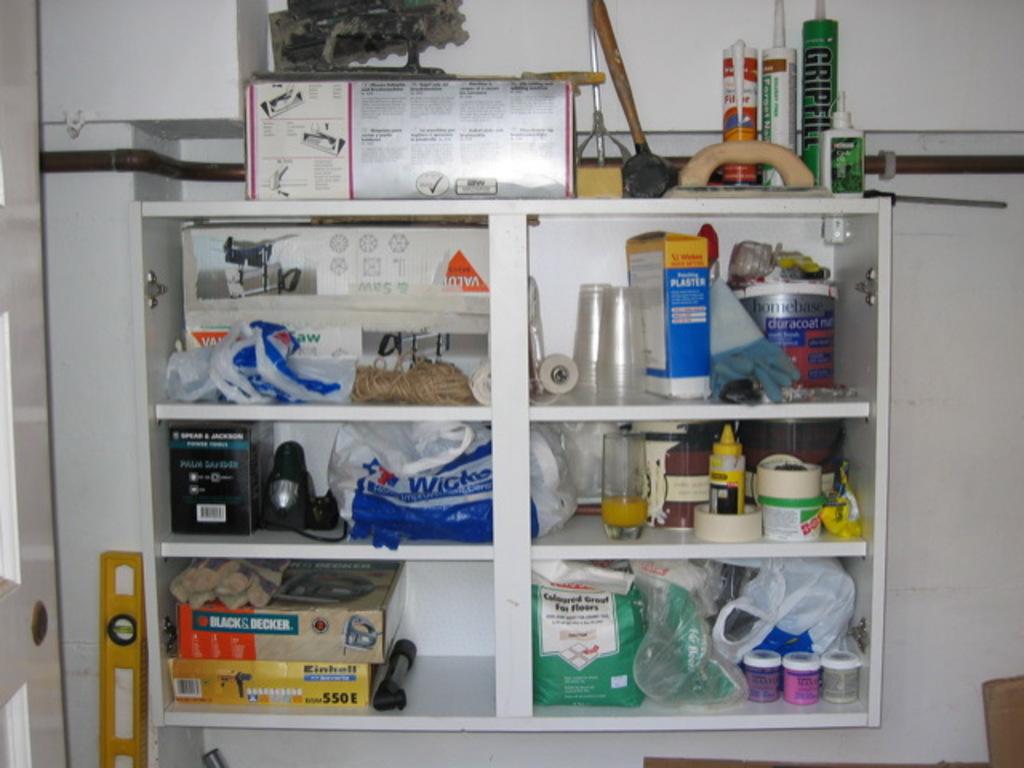What is that green tube?
Your answer should be compact. Gripfill. What are the numbers on the yellow box?
Ensure brevity in your answer.  550. 